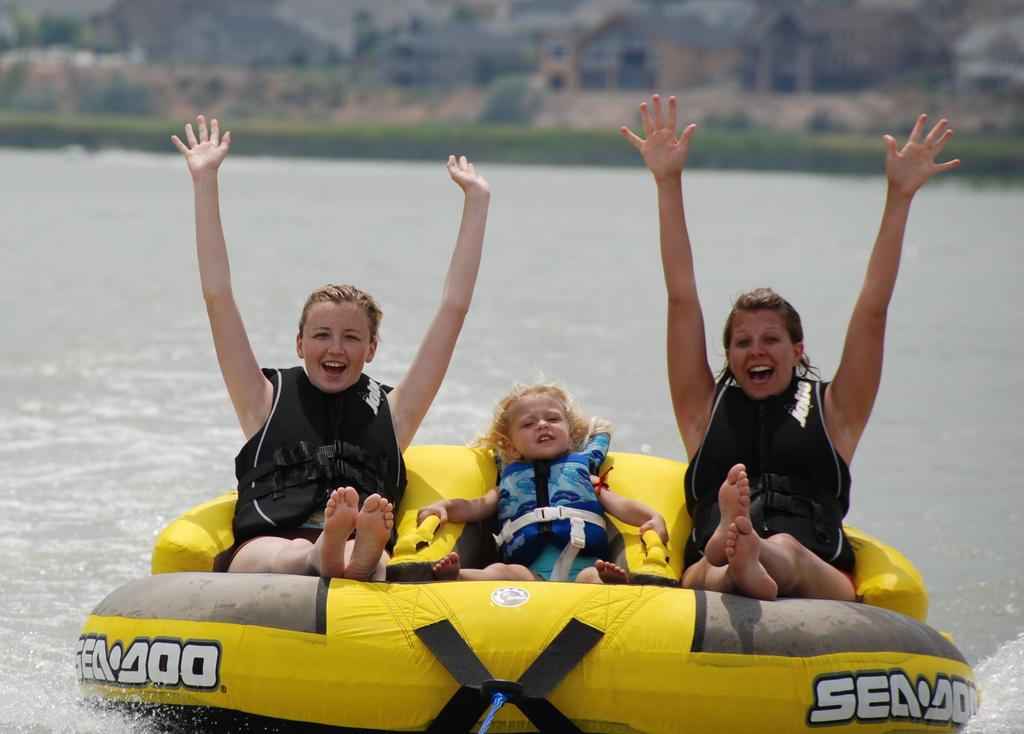How many people are in the image? There are three persons in the image. What are the persons doing in the image? The persons are sitting on a boat and shouting. What can be seen in the background of the image? There are buildings and trees in the background of the image. What is visible at the bottom of the image? There is water visible at the bottom of the image. What type of pets are sitting with the persons on the boat? There are no pets visible in the image; only the three persons are present on the boat. Can you tell me how many times the persons sneeze in the image? There is no indication of sneezing in the image; the persons are shouting, but sneezing is not mentioned or depicted. 